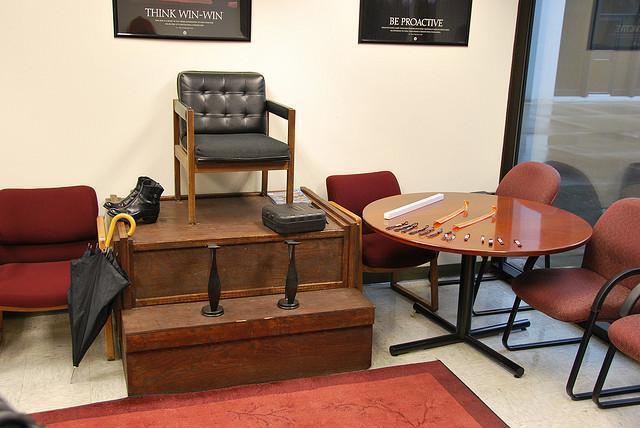How many chairs are in the picture?
Give a very brief answer. 5. 